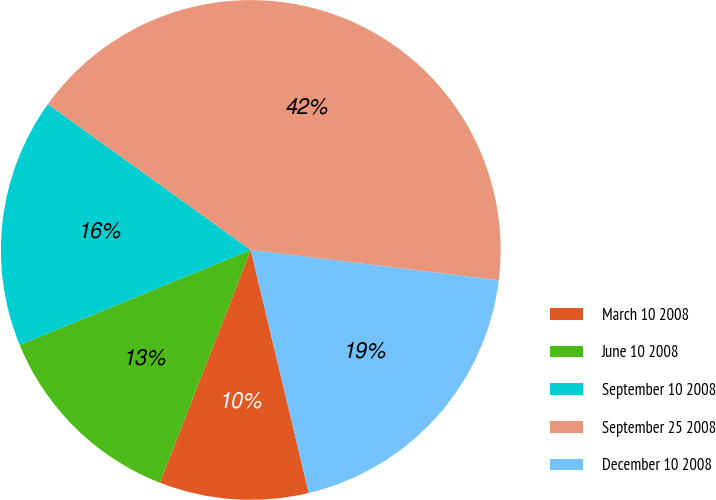Convert chart. <chart><loc_0><loc_0><loc_500><loc_500><pie_chart><fcel>March 10 2008<fcel>June 10 2008<fcel>September 10 2008<fcel>September 25 2008<fcel>December 10 2008<nl><fcel>9.66%<fcel>12.86%<fcel>16.13%<fcel>42.02%<fcel>19.33%<nl></chart> 